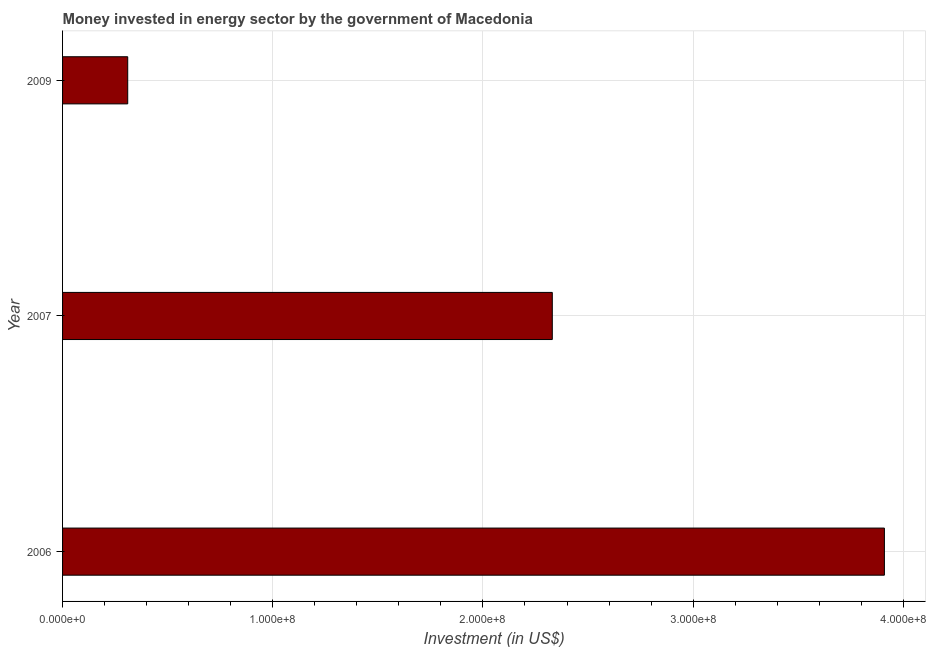Does the graph contain grids?
Offer a very short reply. Yes. What is the title of the graph?
Provide a succinct answer. Money invested in energy sector by the government of Macedonia. What is the label or title of the X-axis?
Your answer should be compact. Investment (in US$). What is the investment in energy in 2007?
Your response must be concise. 2.33e+08. Across all years, what is the maximum investment in energy?
Your answer should be very brief. 3.91e+08. Across all years, what is the minimum investment in energy?
Make the answer very short. 3.10e+07. In which year was the investment in energy minimum?
Provide a short and direct response. 2009. What is the sum of the investment in energy?
Provide a succinct answer. 6.55e+08. What is the difference between the investment in energy in 2006 and 2009?
Make the answer very short. 3.60e+08. What is the average investment in energy per year?
Give a very brief answer. 2.18e+08. What is the median investment in energy?
Ensure brevity in your answer.  2.33e+08. Do a majority of the years between 2009 and 2007 (inclusive) have investment in energy greater than 180000000 US$?
Offer a terse response. No. What is the ratio of the investment in energy in 2006 to that in 2009?
Make the answer very short. 12.61. What is the difference between the highest and the second highest investment in energy?
Offer a very short reply. 1.58e+08. What is the difference between the highest and the lowest investment in energy?
Provide a short and direct response. 3.60e+08. In how many years, is the investment in energy greater than the average investment in energy taken over all years?
Provide a short and direct response. 2. Are all the bars in the graph horizontal?
Offer a terse response. Yes. What is the Investment (in US$) in 2006?
Keep it short and to the point. 3.91e+08. What is the Investment (in US$) in 2007?
Offer a very short reply. 2.33e+08. What is the Investment (in US$) in 2009?
Provide a succinct answer. 3.10e+07. What is the difference between the Investment (in US$) in 2006 and 2007?
Offer a terse response. 1.58e+08. What is the difference between the Investment (in US$) in 2006 and 2009?
Keep it short and to the point. 3.60e+08. What is the difference between the Investment (in US$) in 2007 and 2009?
Ensure brevity in your answer.  2.02e+08. What is the ratio of the Investment (in US$) in 2006 to that in 2007?
Provide a short and direct response. 1.68. What is the ratio of the Investment (in US$) in 2006 to that in 2009?
Your answer should be compact. 12.61. What is the ratio of the Investment (in US$) in 2007 to that in 2009?
Give a very brief answer. 7.52. 